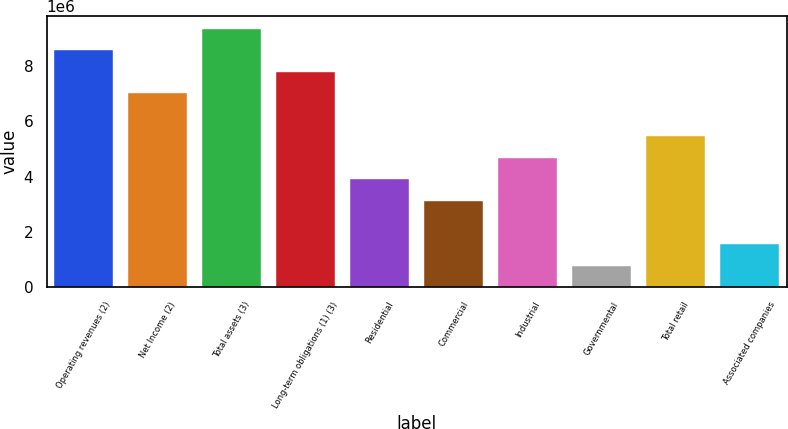Convert chart to OTSL. <chart><loc_0><loc_0><loc_500><loc_500><bar_chart><fcel>Operating revenues (2)<fcel>Net Income (2)<fcel>Total assets (3)<fcel>Long-term obligations (1) (3)<fcel>Residential<fcel>Commercial<fcel>Industrial<fcel>Governmental<fcel>Total retail<fcel>Associated companies<nl><fcel>8.56534e+06<fcel>7.00801e+06<fcel>9.344e+06<fcel>7.78668e+06<fcel>3.89336e+06<fcel>3.1147e+06<fcel>4.67202e+06<fcel>778710<fcel>5.45069e+06<fcel>1.55737e+06<nl></chart> 